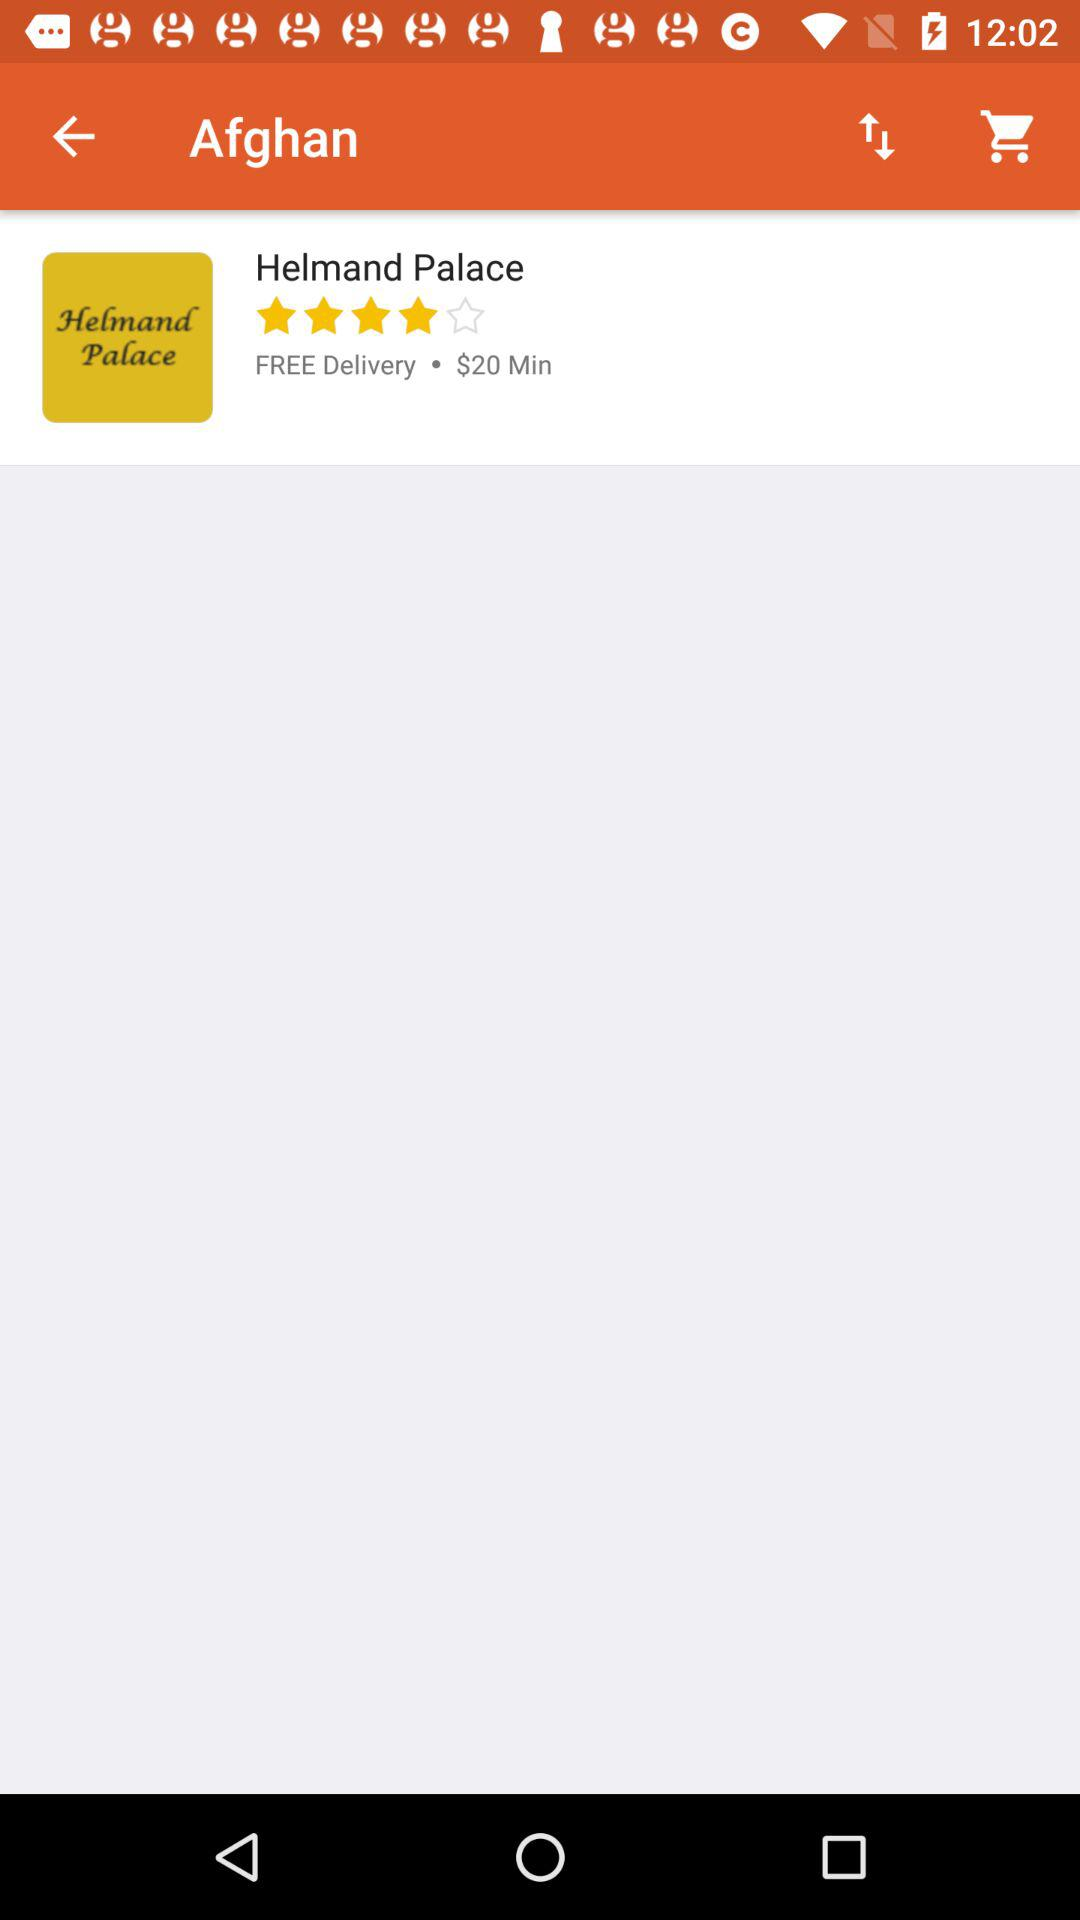What is the name of the Palace? The name of the palace is Helmand. 